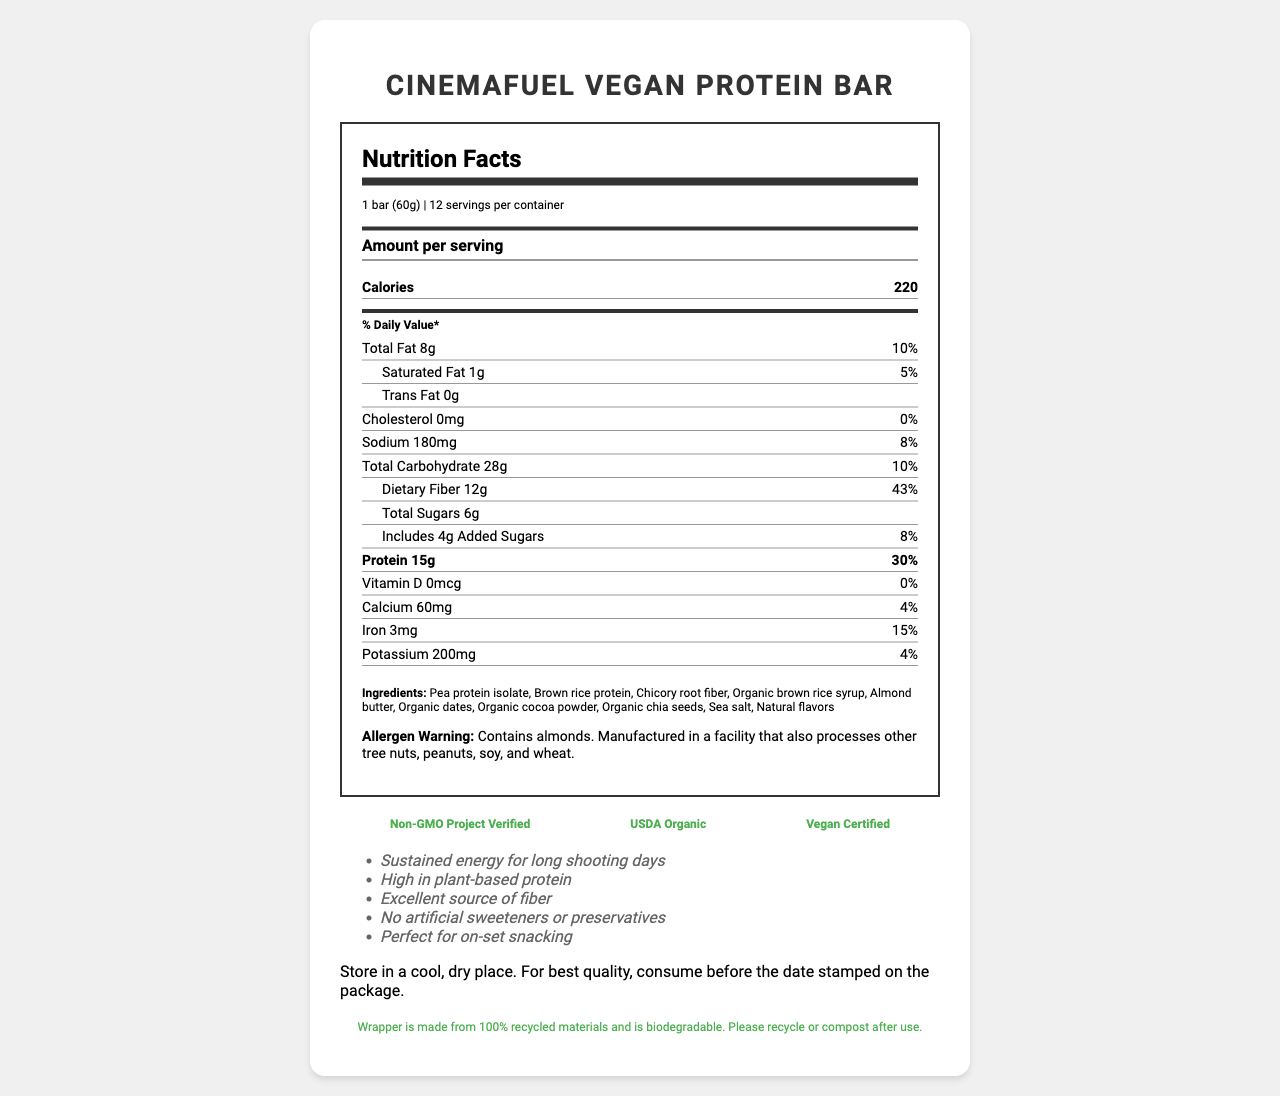what is the product name? The product name is at the top of the document and in a larger font compared to other text.
Answer: CinemaFuel Vegan Protein Bar what is the serving size? The serving size is mentioned under the "Nutrition Facts" header in the serving info section.
Answer: 1 bar (60g) how many calories are there per serving? Under the "Amount per serving" section, the document lists the calories as 220.
Answer: 220 what is the amount of dietary fiber per serving? Under the "Daily Value" section, dietary fiber is listed as 12g.
Answer: 12g list one ingredient in the CinemaFuel Vegan Protein Bar. The ingredients are provided towards the bottom of the document.
Answer: Pea protein isolate how many servings are in one container? It is mentioned right after the serving size in the serving info section.
Answer: 12 what is the daily value percentage of protein? The daily value percentage for protein is listed under the detailed nutrient rows as 30%.
Answer: 30% what is the sodium content per serving? The amount of sodium per serving is listed under the sodium section: 180mg.
Answer: 180mg how much added sugar does one bar contain? The added sugars amount is provided under the sub-nutrient information for sugars.
Answer: 4g which of the following is not an ingredient in the CinemaFuel Vegan Protein Bar? A. Almond butter B. Corn syrup C. Organic chia seeds D. Sea salt Corn syrup is not listed among the ingredients.
Answer: B which certification is NOT obtained by the CinemaFuel Vegan Protein Bar? I. Non-GMO Project Verified II. USDA Organic III. Vegan Certified IV. Gluten-Free The certifications listed are Non-GMO Project Verified, USDA Organic, and Vegan Certified; Gluten-Free is not listed.
Answer: IV. Gluten-Free does the product contain any allergens? The allergen warning indicates it contains almonds and mentions cross-contamination with other tree nuts, peanuts, soy, and wheat.
Answer: Yes is the CinemaFuel Vegan Protein Bar suitable for vegans? The product is certified as Vegan, mentioned under the certifications section.
Answer: Yes what is the main idea of the document? The document covers various aspects of the product, from nutritional content and ingredients to certifications and marketing claims, aiming to present it as a health-conscious snack for film crew members.
Answer: The document provides detailed nutritional information, ingredients, allergen warnings, certifications, marketing claims, storage instructions, and sustainability info for the CinemaFuel Vegan Protein Bar. The bar is geared towards health-conscious individuals, especially film crew members, offering high protein and fiber. what is the exact percentage of the daily value for iron per serving? The daily value percentage for iron is listed under the nutrient row for iron as 15%.
Answer: 15% where is HealthySet Nutrition, Inc. located? The manufacturer’s address is provided under the manufacturer info section at the end of the document.
Answer: 123 Production Ave, Hollywood, CA 90028 what is the phone number for contacting the manufacturer? The contact phone number is listed under the manufacturer info.
Answer: 1-800-555-FILM when is the best time to consume the CinemaFuel Vegan Protein Bar for optimal quality? The storage instructions advise consuming the product before the date stamped on the package for the best quality.
Answer: Before the date stamped on the package how much potassium is in one serving? The potassium content is listed near the bottom of the nutrient rows as 200mg.
Answer: 200mg who is the manufacturer of the CinemaFuel Vegan Protein Bar? The manufacturer's name is listed towards the end of the document under the manufacturer info.
Answer: HealthySet Nutrition, Inc. what are the total grams of sugars, including added sugars, in one serving? The document lists total sugars as 6g and specifies that 4g are added sugars.
Answer: 6g total sugars and 4g added sugars what is the wrapper material of the CinemaFuel Vegan Protein Bar? The sustainability info mentions that the wrapper is made from recycled and biodegradable materials.
Answer: Wrapper is made from 100% recycled materials and is biodegradable how does the CinemaFuel Vegan Protein Bar support long shooting days? One of the marketing claims states that the bar provides sustained energy for long shooting days.
Answer: By providing sustained energy is there any information on the net weight of the entire container? The document specifies the serving size (60g) and the number of servings per container (12), but does not explicitly state the net weight of the entire container.
Answer: Not enough information 